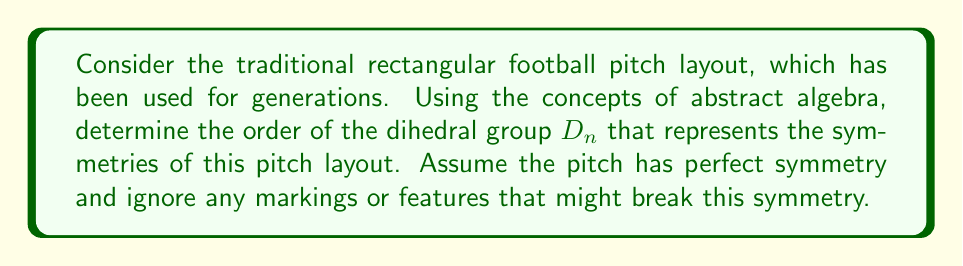Can you solve this math problem? Let's approach this step-by-step:

1) First, recall that a rectangular football pitch has four sides and four corners.

2) In abstract algebra, the symmetries of a regular polygon with $n$ sides are described by the dihedral group $D_n$.

3) For a rectangle, we need to consider two types of symmetries:
   a) Rotational symmetries
   b) Reflection symmetries

4) Rotational symmetries:
   - A rectangle has rotational symmetry of order 2, meaning it can be rotated by 180° and look the same.
   - This gives us 2 rotational symmetries (including the identity rotation of 0°).

5) Reflection symmetries:
   - A rectangle has 4 lines of symmetry:
     i) Two diagonals
     ii) One vertical line through the center
     iii) One horizontal line through the center
   - This gives us 4 reflection symmetries.

6) The total number of symmetries is the sum of rotational and reflection symmetries:
   $2 + 4 = 6$

7) In the dihedral group notation, this corresponds to $D_4$, because:
   - The order of $D_n$ is always $2n$
   - Here, the order is 6, so $2n = 6$
   - Solving for $n$: $n = 3$

8) However, we conventionally use $D_4$ for a rectangle, not $D_3$, because it has 4 sides.

Therefore, the symmetries of a rectangular football pitch are represented by the dihedral group $D_4$.
Answer: The order of the dihedral group representing the symmetries of a rectangular football pitch is $D_4$, which has order 8. 